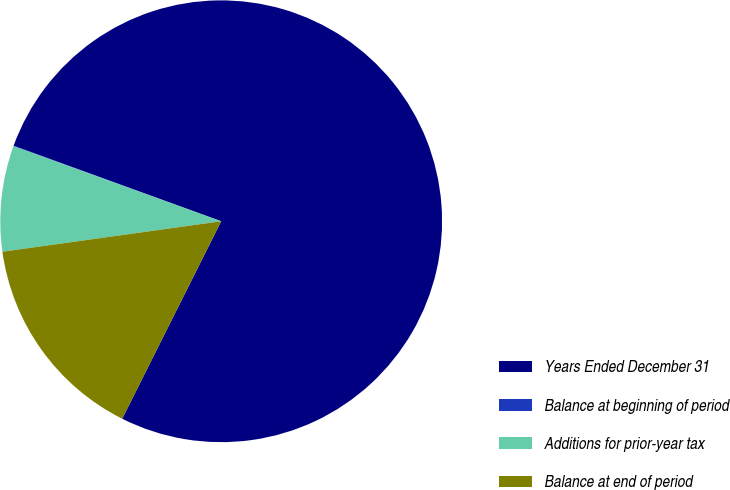Convert chart to OTSL. <chart><loc_0><loc_0><loc_500><loc_500><pie_chart><fcel>Years Ended December 31<fcel>Balance at beginning of period<fcel>Additions for prior-year tax<fcel>Balance at end of period<nl><fcel>76.84%<fcel>0.04%<fcel>7.72%<fcel>15.4%<nl></chart> 